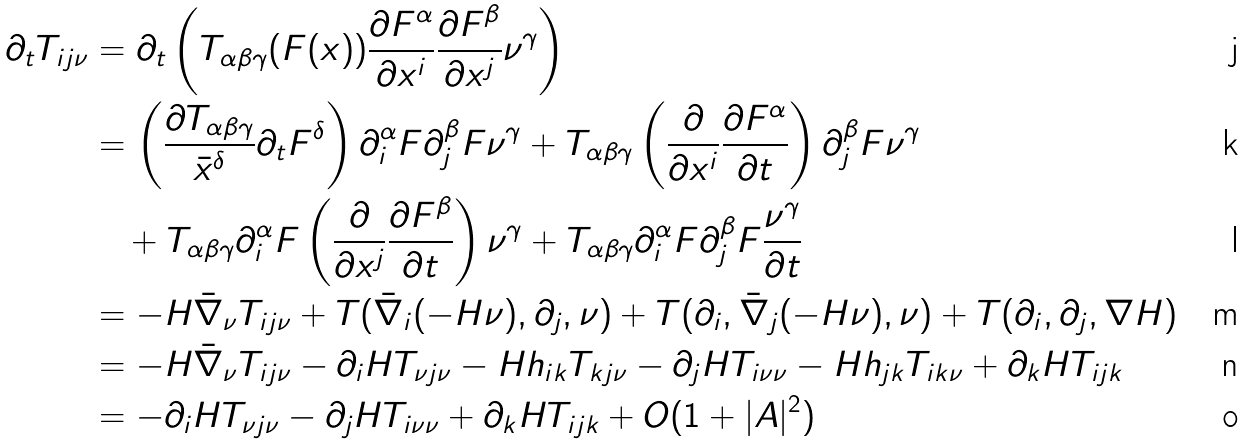<formula> <loc_0><loc_0><loc_500><loc_500>\partial _ { t } T _ { i j \nu } & = \partial _ { t } \left ( T _ { \alpha \beta \gamma } ( F ( x ) ) \frac { \partial F ^ { \alpha } } { \partial x ^ { i } } \frac { \partial F ^ { \beta } } { \partial x ^ { j } } \nu ^ { \gamma } \right ) \\ & = \left ( \frac { \partial T _ { \alpha \beta \gamma } } { \bar { x } ^ { \delta } } \partial _ { t } F ^ { \delta } \right ) \partial _ { i } ^ { \alpha } F \partial _ { j } ^ { \beta } F \nu ^ { \gamma } + T _ { \alpha \beta \gamma } \left ( \frac { \partial } { \partial x ^ { i } } \frac { \partial F ^ { \alpha } } { \partial t } \right ) \partial _ { j } ^ { \beta } F \nu ^ { \gamma } \\ & \quad + T _ { \alpha \beta \gamma } \partial _ { i } ^ { \alpha } F \left ( \frac { \partial } { \partial x ^ { j } } \frac { \partial F ^ { \beta } } { \partial t } \right ) \nu ^ { \gamma } + T _ { \alpha \beta \gamma } \partial _ { i } ^ { \alpha } F \partial _ { j } ^ { \beta } F \frac { \nu ^ { \gamma } } { \partial t } \\ & = - H \bar { \nabla } _ { \nu } T _ { i j \nu } + T ( \bar { \nabla } _ { i } ( - H \nu ) , \partial _ { j } , \nu ) + T ( \partial _ { i } , \bar { \nabla } _ { j } ( - H \nu ) , \nu ) + T ( \partial _ { i } , \partial _ { j } , \nabla H ) \\ & = - H \bar { \nabla } _ { \nu } T _ { i j \nu } - \partial _ { i } H T _ { \nu j \nu } - H h _ { i k } T _ { k j \nu } - \partial _ { j } H T _ { i \nu \nu } - H h _ { j k } T _ { i k \nu } + \partial _ { k } H T _ { i j k } \\ & = - \partial _ { i } H T _ { \nu j \nu } - \partial _ { j } H T _ { i \nu \nu } + \partial _ { k } H T _ { i j k } + O ( 1 + | A | ^ { 2 } )</formula> 